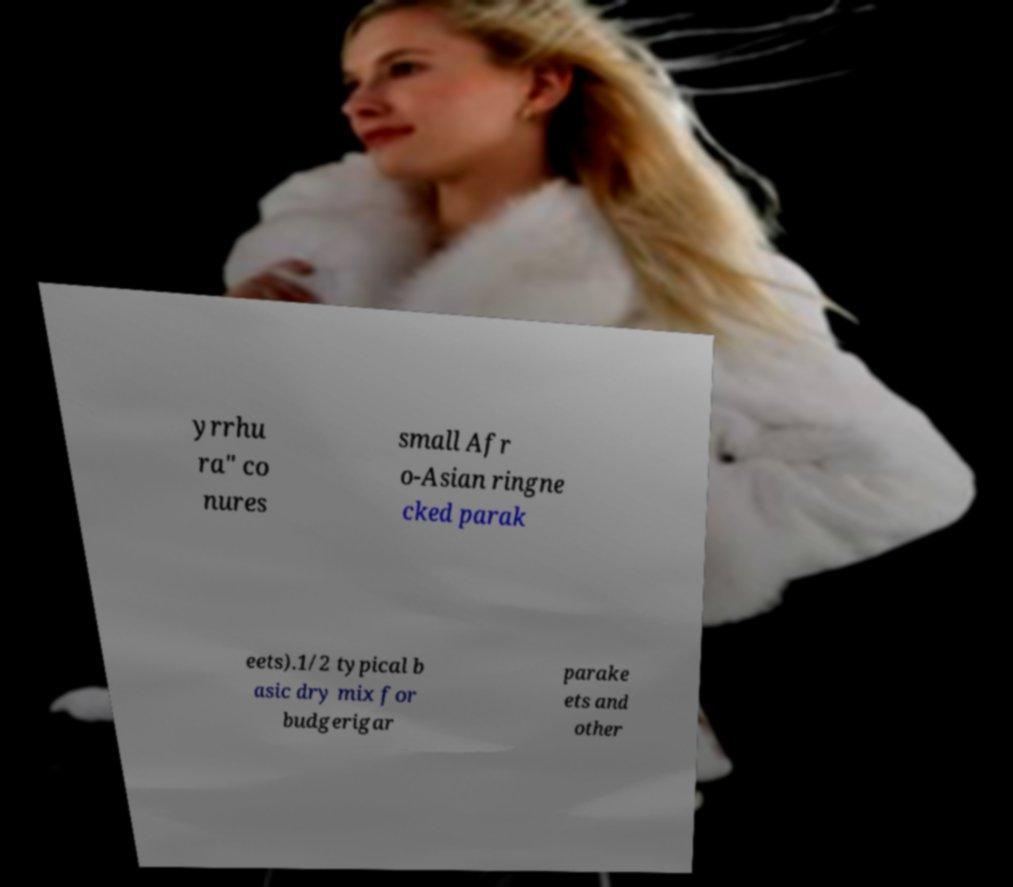Please identify and transcribe the text found in this image. yrrhu ra" co nures small Afr o-Asian ringne cked parak eets).1/2 typical b asic dry mix for budgerigar parake ets and other 